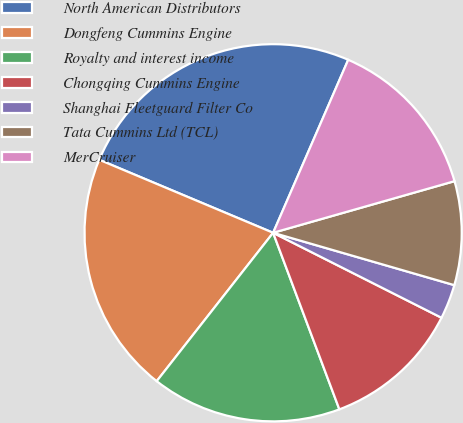Convert chart. <chart><loc_0><loc_0><loc_500><loc_500><pie_chart><fcel>North American Distributors<fcel>Dongfeng Cummins Engine<fcel>Royalty and interest income<fcel>Chongqing Cummins Engine<fcel>Shanghai Fleetguard Filter Co<fcel>Tata Cummins Ltd (TCL)<fcel>MerCruiser<nl><fcel>25.19%<fcel>20.74%<fcel>16.3%<fcel>11.85%<fcel>2.96%<fcel>8.89%<fcel>14.07%<nl></chart> 